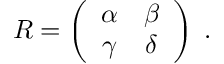Convert formula to latex. <formula><loc_0><loc_0><loc_500><loc_500>R = \left ( \begin{array} { c c } { \alpha } & { \beta } \\ { \gamma } & { \delta } \end{array} \right ) \, .</formula> 